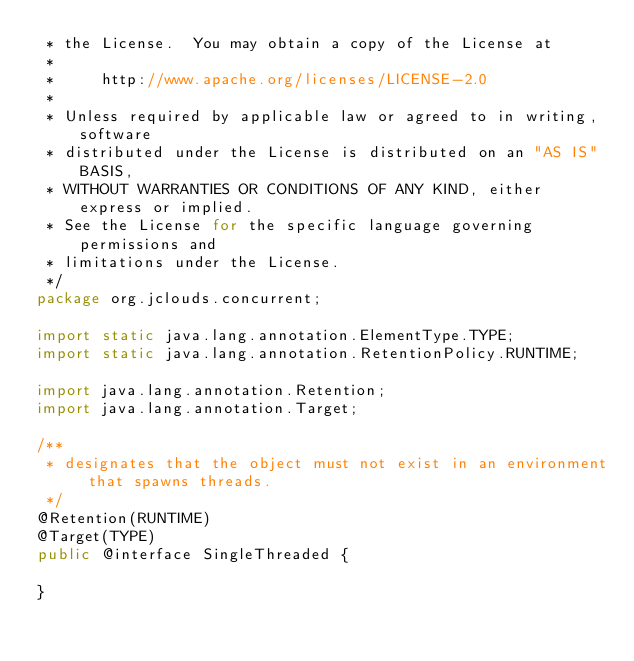<code> <loc_0><loc_0><loc_500><loc_500><_Java_> * the License.  You may obtain a copy of the License at
 *
 *     http://www.apache.org/licenses/LICENSE-2.0
 *
 * Unless required by applicable law or agreed to in writing, software
 * distributed under the License is distributed on an "AS IS" BASIS,
 * WITHOUT WARRANTIES OR CONDITIONS OF ANY KIND, either express or implied.
 * See the License for the specific language governing permissions and
 * limitations under the License.
 */
package org.jclouds.concurrent;

import static java.lang.annotation.ElementType.TYPE;
import static java.lang.annotation.RetentionPolicy.RUNTIME;

import java.lang.annotation.Retention;
import java.lang.annotation.Target;

/**
 * designates that the object must not exist in an environment that spawns threads.
 */
@Retention(RUNTIME)
@Target(TYPE)
public @interface SingleThreaded {

}
</code> 